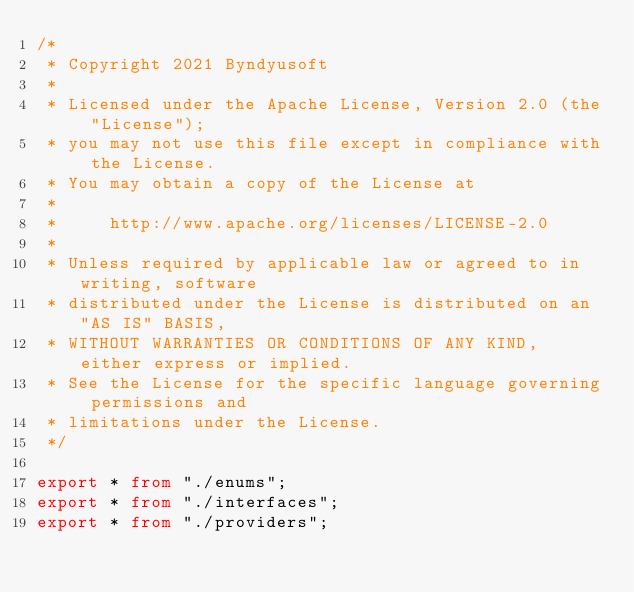Convert code to text. <code><loc_0><loc_0><loc_500><loc_500><_TypeScript_>/*
 * Copyright 2021 Byndyusoft
 *
 * Licensed under the Apache License, Version 2.0 (the "License");
 * you may not use this file except in compliance with the License.
 * You may obtain a copy of the License at
 *
 *     http://www.apache.org/licenses/LICENSE-2.0
 *
 * Unless required by applicable law or agreed to in writing, software
 * distributed under the License is distributed on an "AS IS" BASIS,
 * WITHOUT WARRANTIES OR CONDITIONS OF ANY KIND, either express or implied.
 * See the License for the specific language governing permissions and
 * limitations under the License.
 */

export * from "./enums";
export * from "./interfaces";
export * from "./providers";
</code> 